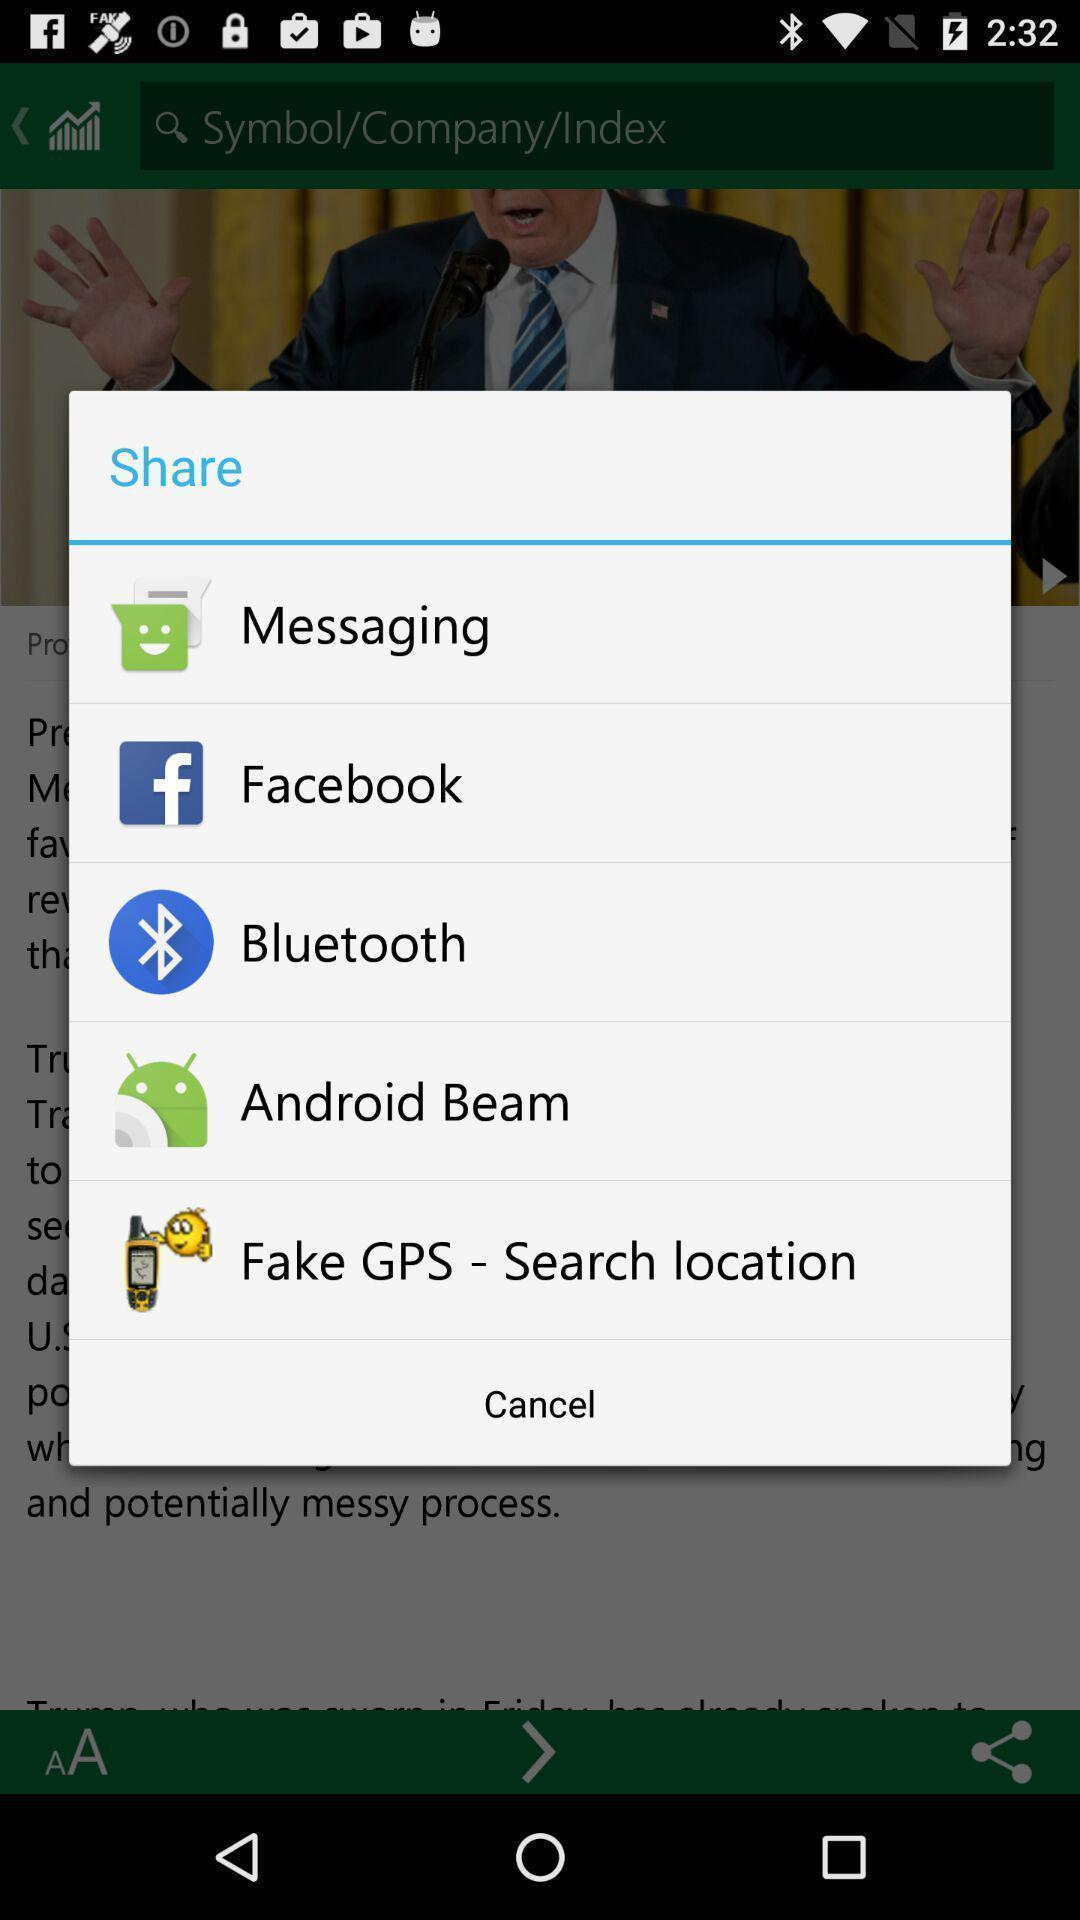Give me a narrative description of this picture. Pop-up showing the multiple share options. 